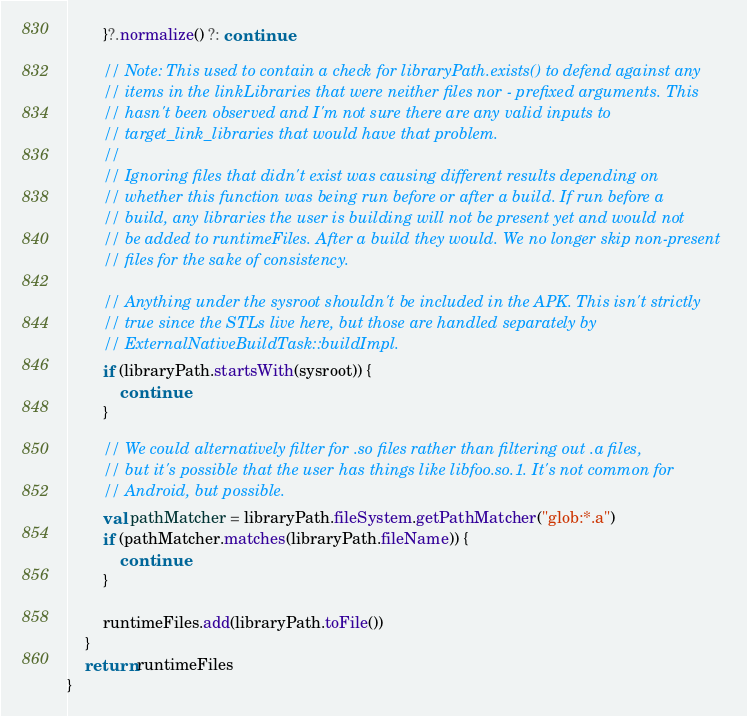<code> <loc_0><loc_0><loc_500><loc_500><_Kotlin_>        }?.normalize() ?: continue

        // Note: This used to contain a check for libraryPath.exists() to defend against any
        // items in the linkLibraries that were neither files nor - prefixed arguments. This
        // hasn't been observed and I'm not sure there are any valid inputs to
        // target_link_libraries that would have that problem.
        //
        // Ignoring files that didn't exist was causing different results depending on
        // whether this function was being run before or after a build. If run before a
        // build, any libraries the user is building will not be present yet and would not
        // be added to runtimeFiles. After a build they would. We no longer skip non-present
        // files for the sake of consistency.

        // Anything under the sysroot shouldn't be included in the APK. This isn't strictly
        // true since the STLs live here, but those are handled separately by
        // ExternalNativeBuildTask::buildImpl.
        if (libraryPath.startsWith(sysroot)) {
            continue
        }

        // We could alternatively filter for .so files rather than filtering out .a files,
        // but it's possible that the user has things like libfoo.so.1. It's not common for
        // Android, but possible.
        val pathMatcher = libraryPath.fileSystem.getPathMatcher("glob:*.a")
        if (pathMatcher.matches(libraryPath.fileName)) {
            continue
        }

        runtimeFiles.add(libraryPath.toFile())
    }
    return runtimeFiles
}
</code> 